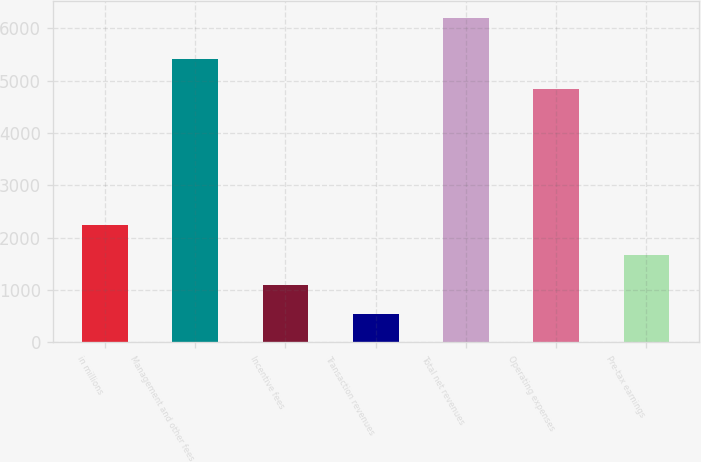<chart> <loc_0><loc_0><loc_500><loc_500><bar_chart><fcel>in millions<fcel>Management and other fees<fcel>Incentive fees<fcel>Transaction revenues<fcel>Total net revenues<fcel>Operating expenses<fcel>Pre-tax earnings<nl><fcel>2239.1<fcel>5407.7<fcel>1105.7<fcel>539<fcel>6206<fcel>4841<fcel>1672.4<nl></chart> 